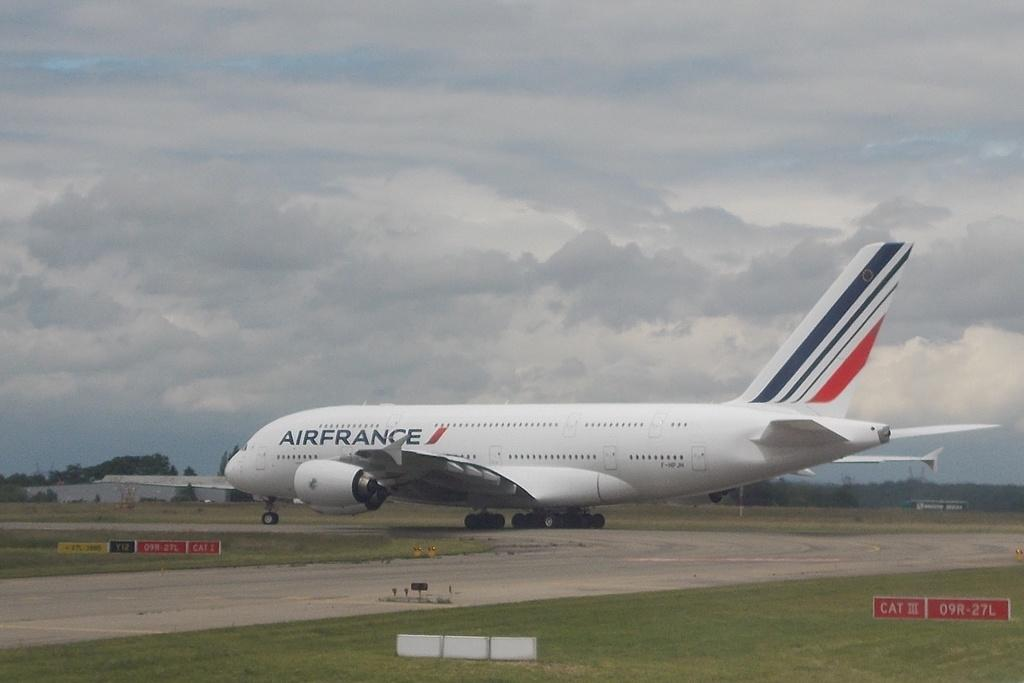<image>
Render a clear and concise summary of the photo. A plane owned by Air France on a runway. 